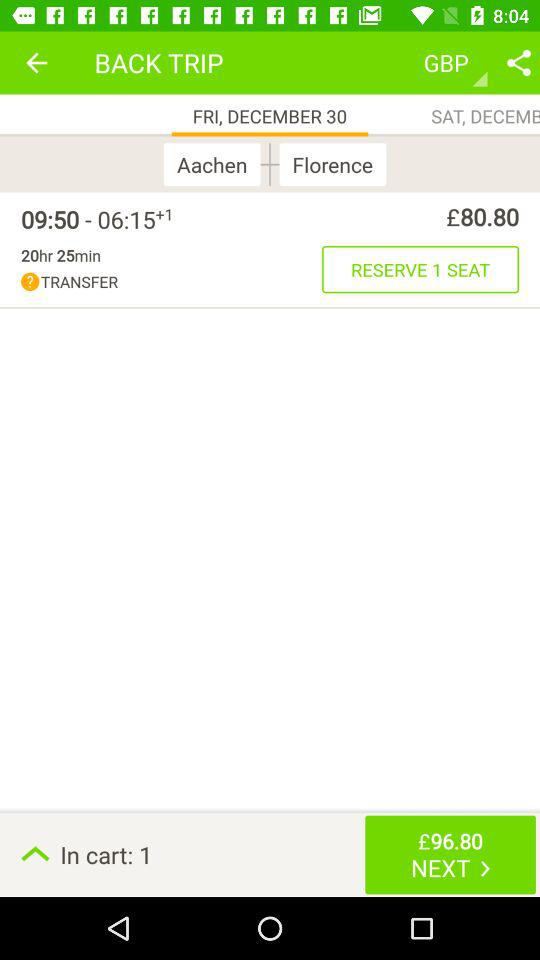How much is the total amount to be paid? The total amount to be paid is £96.80. 